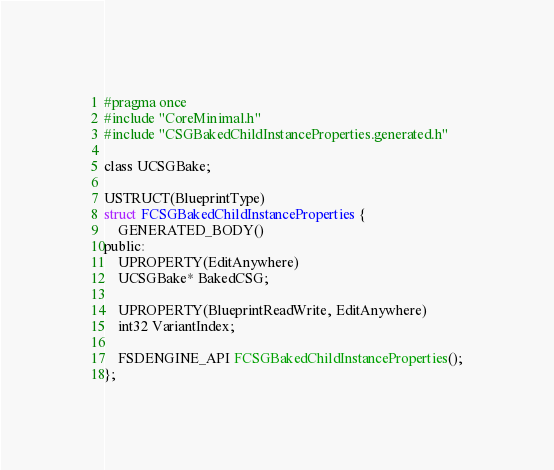Convert code to text. <code><loc_0><loc_0><loc_500><loc_500><_C_>#pragma once
#include "CoreMinimal.h"
#include "CSGBakedChildInstanceProperties.generated.h"

class UCSGBake;

USTRUCT(BlueprintType)
struct FCSGBakedChildInstanceProperties {
    GENERATED_BODY()
public:
    UPROPERTY(EditAnywhere)
    UCSGBake* BakedCSG;
    
    UPROPERTY(BlueprintReadWrite, EditAnywhere)
    int32 VariantIndex;
    
    FSDENGINE_API FCSGBakedChildInstanceProperties();
};

</code> 